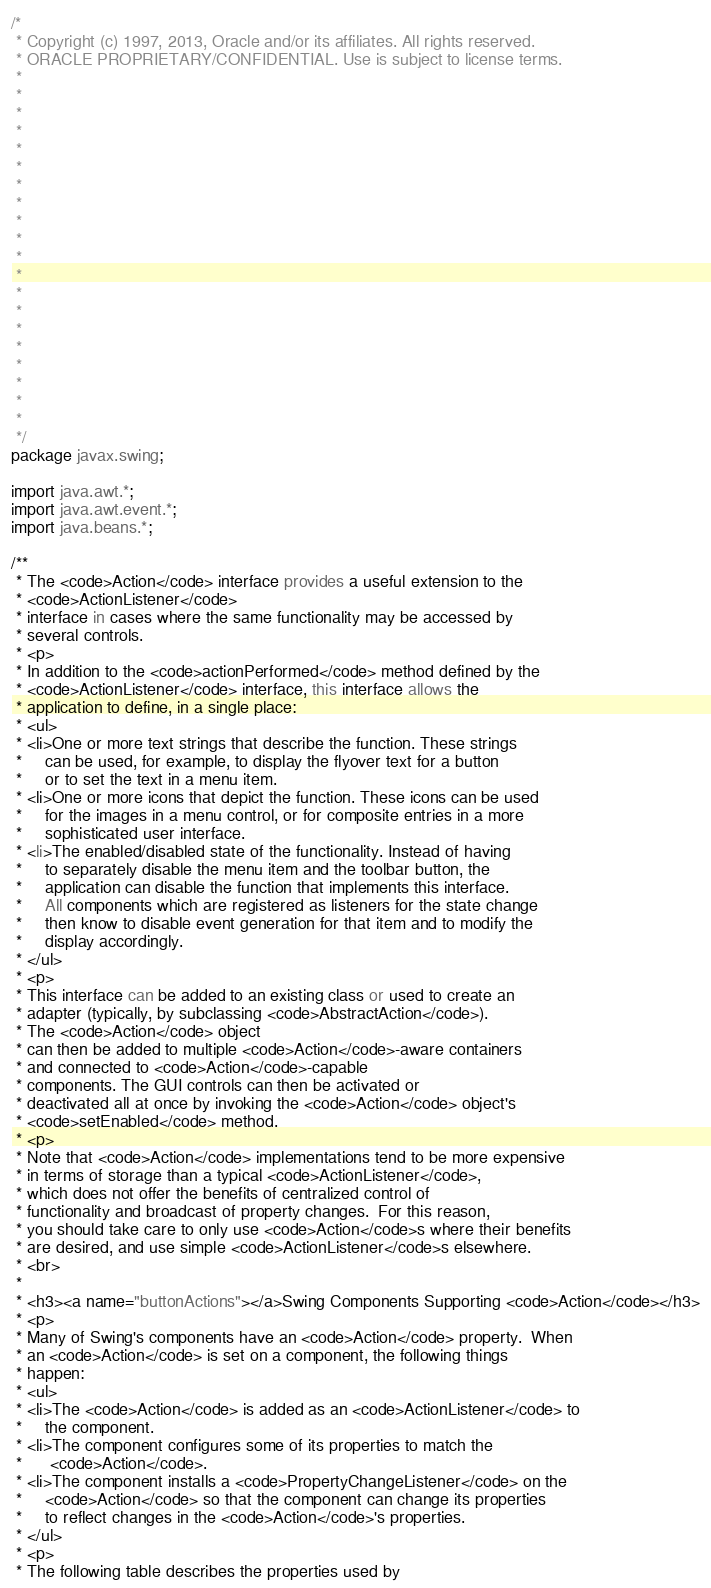Convert code to text. <code><loc_0><loc_0><loc_500><loc_500><_Java_>/*
 * Copyright (c) 1997, 2013, Oracle and/or its affiliates. All rights reserved.
 * ORACLE PROPRIETARY/CONFIDENTIAL. Use is subject to license terms.
 *
 *
 *
 *
 *
 *
 *
 *
 *
 *
 *
 *
 *
 *
 *
 *
 *
 *
 *
 *
 */
package javax.swing;

import java.awt.*;
import java.awt.event.*;
import java.beans.*;

/**
 * The <code>Action</code> interface provides a useful extension to the
 * <code>ActionListener</code>
 * interface in cases where the same functionality may be accessed by
 * several controls.
 * <p>
 * In addition to the <code>actionPerformed</code> method defined by the
 * <code>ActionListener</code> interface, this interface allows the
 * application to define, in a single place:
 * <ul>
 * <li>One or more text strings that describe the function. These strings
 *     can be used, for example, to display the flyover text for a button
 *     or to set the text in a menu item.
 * <li>One or more icons that depict the function. These icons can be used
 *     for the images in a menu control, or for composite entries in a more
 *     sophisticated user interface.
 * <li>The enabled/disabled state of the functionality. Instead of having
 *     to separately disable the menu item and the toolbar button, the
 *     application can disable the function that implements this interface.
 *     All components which are registered as listeners for the state change
 *     then know to disable event generation for that item and to modify the
 *     display accordingly.
 * </ul>
 * <p>
 * This interface can be added to an existing class or used to create an
 * adapter (typically, by subclassing <code>AbstractAction</code>).
 * The <code>Action</code> object
 * can then be added to multiple <code>Action</code>-aware containers
 * and connected to <code>Action</code>-capable
 * components. The GUI controls can then be activated or
 * deactivated all at once by invoking the <code>Action</code> object's
 * <code>setEnabled</code> method.
 * <p>
 * Note that <code>Action</code> implementations tend to be more expensive
 * in terms of storage than a typical <code>ActionListener</code>,
 * which does not offer the benefits of centralized control of
 * functionality and broadcast of property changes.  For this reason,
 * you should take care to only use <code>Action</code>s where their benefits
 * are desired, and use simple <code>ActionListener</code>s elsewhere.
 * <br>
 *
 * <h3><a name="buttonActions"></a>Swing Components Supporting <code>Action</code></h3>
 * <p>
 * Many of Swing's components have an <code>Action</code> property.  When
 * an <code>Action</code> is set on a component, the following things
 * happen:
 * <ul>
 * <li>The <code>Action</code> is added as an <code>ActionListener</code> to
 *     the component.
 * <li>The component configures some of its properties to match the
 *      <code>Action</code>.
 * <li>The component installs a <code>PropertyChangeListener</code> on the
 *     <code>Action</code> so that the component can change its properties
 *     to reflect changes in the <code>Action</code>'s properties.
 * </ul>
 * <p>
 * The following table describes the properties used by</code> 